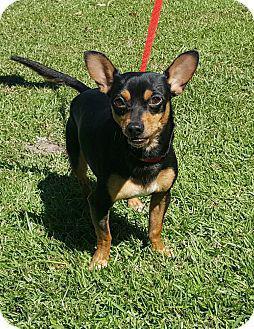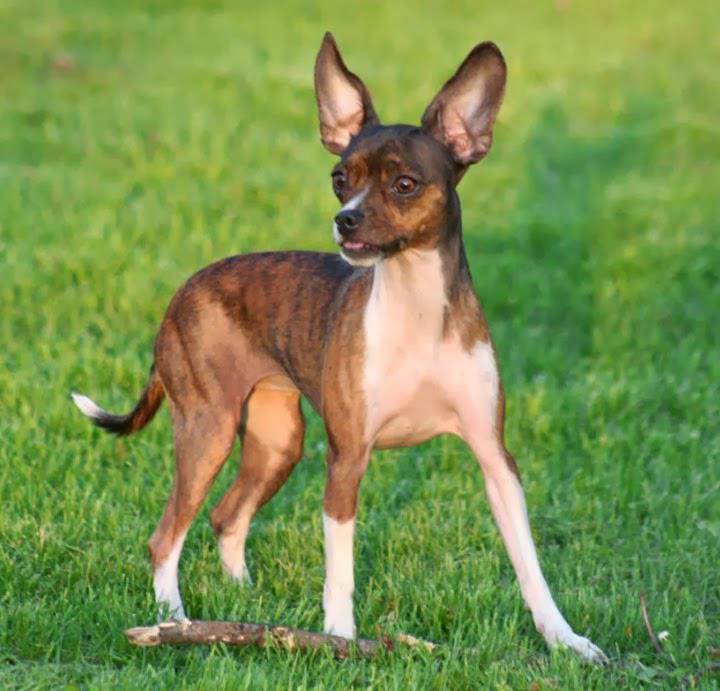The first image is the image on the left, the second image is the image on the right. Analyze the images presented: Is the assertion "A dog in one image is photographed while in mid-air." valid? Answer yes or no. No. 